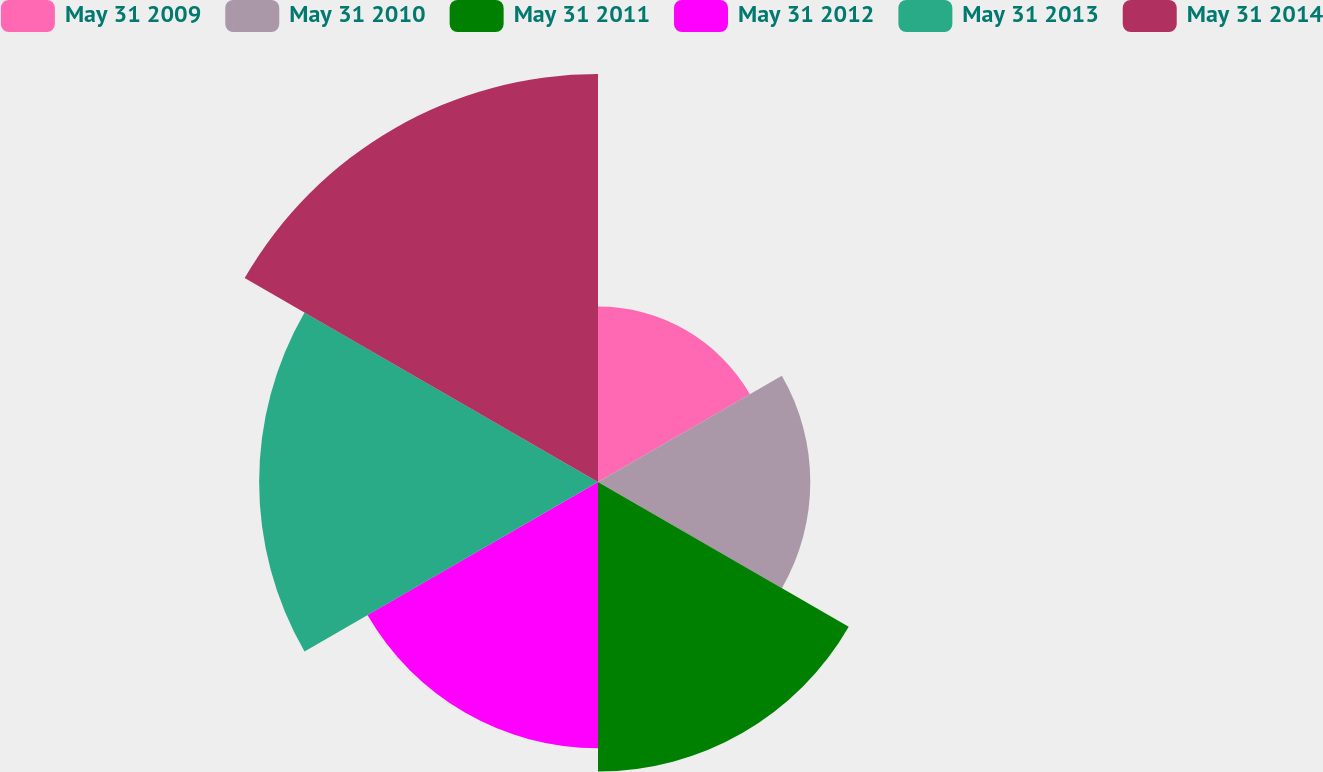<chart> <loc_0><loc_0><loc_500><loc_500><pie_chart><fcel>May 31 2009<fcel>May 31 2010<fcel>May 31 2011<fcel>May 31 2012<fcel>May 31 2013<fcel>May 31 2014<nl><fcel>10.38%<fcel>12.56%<fcel>17.13%<fcel>15.75%<fcel>20.05%<fcel>24.14%<nl></chart> 